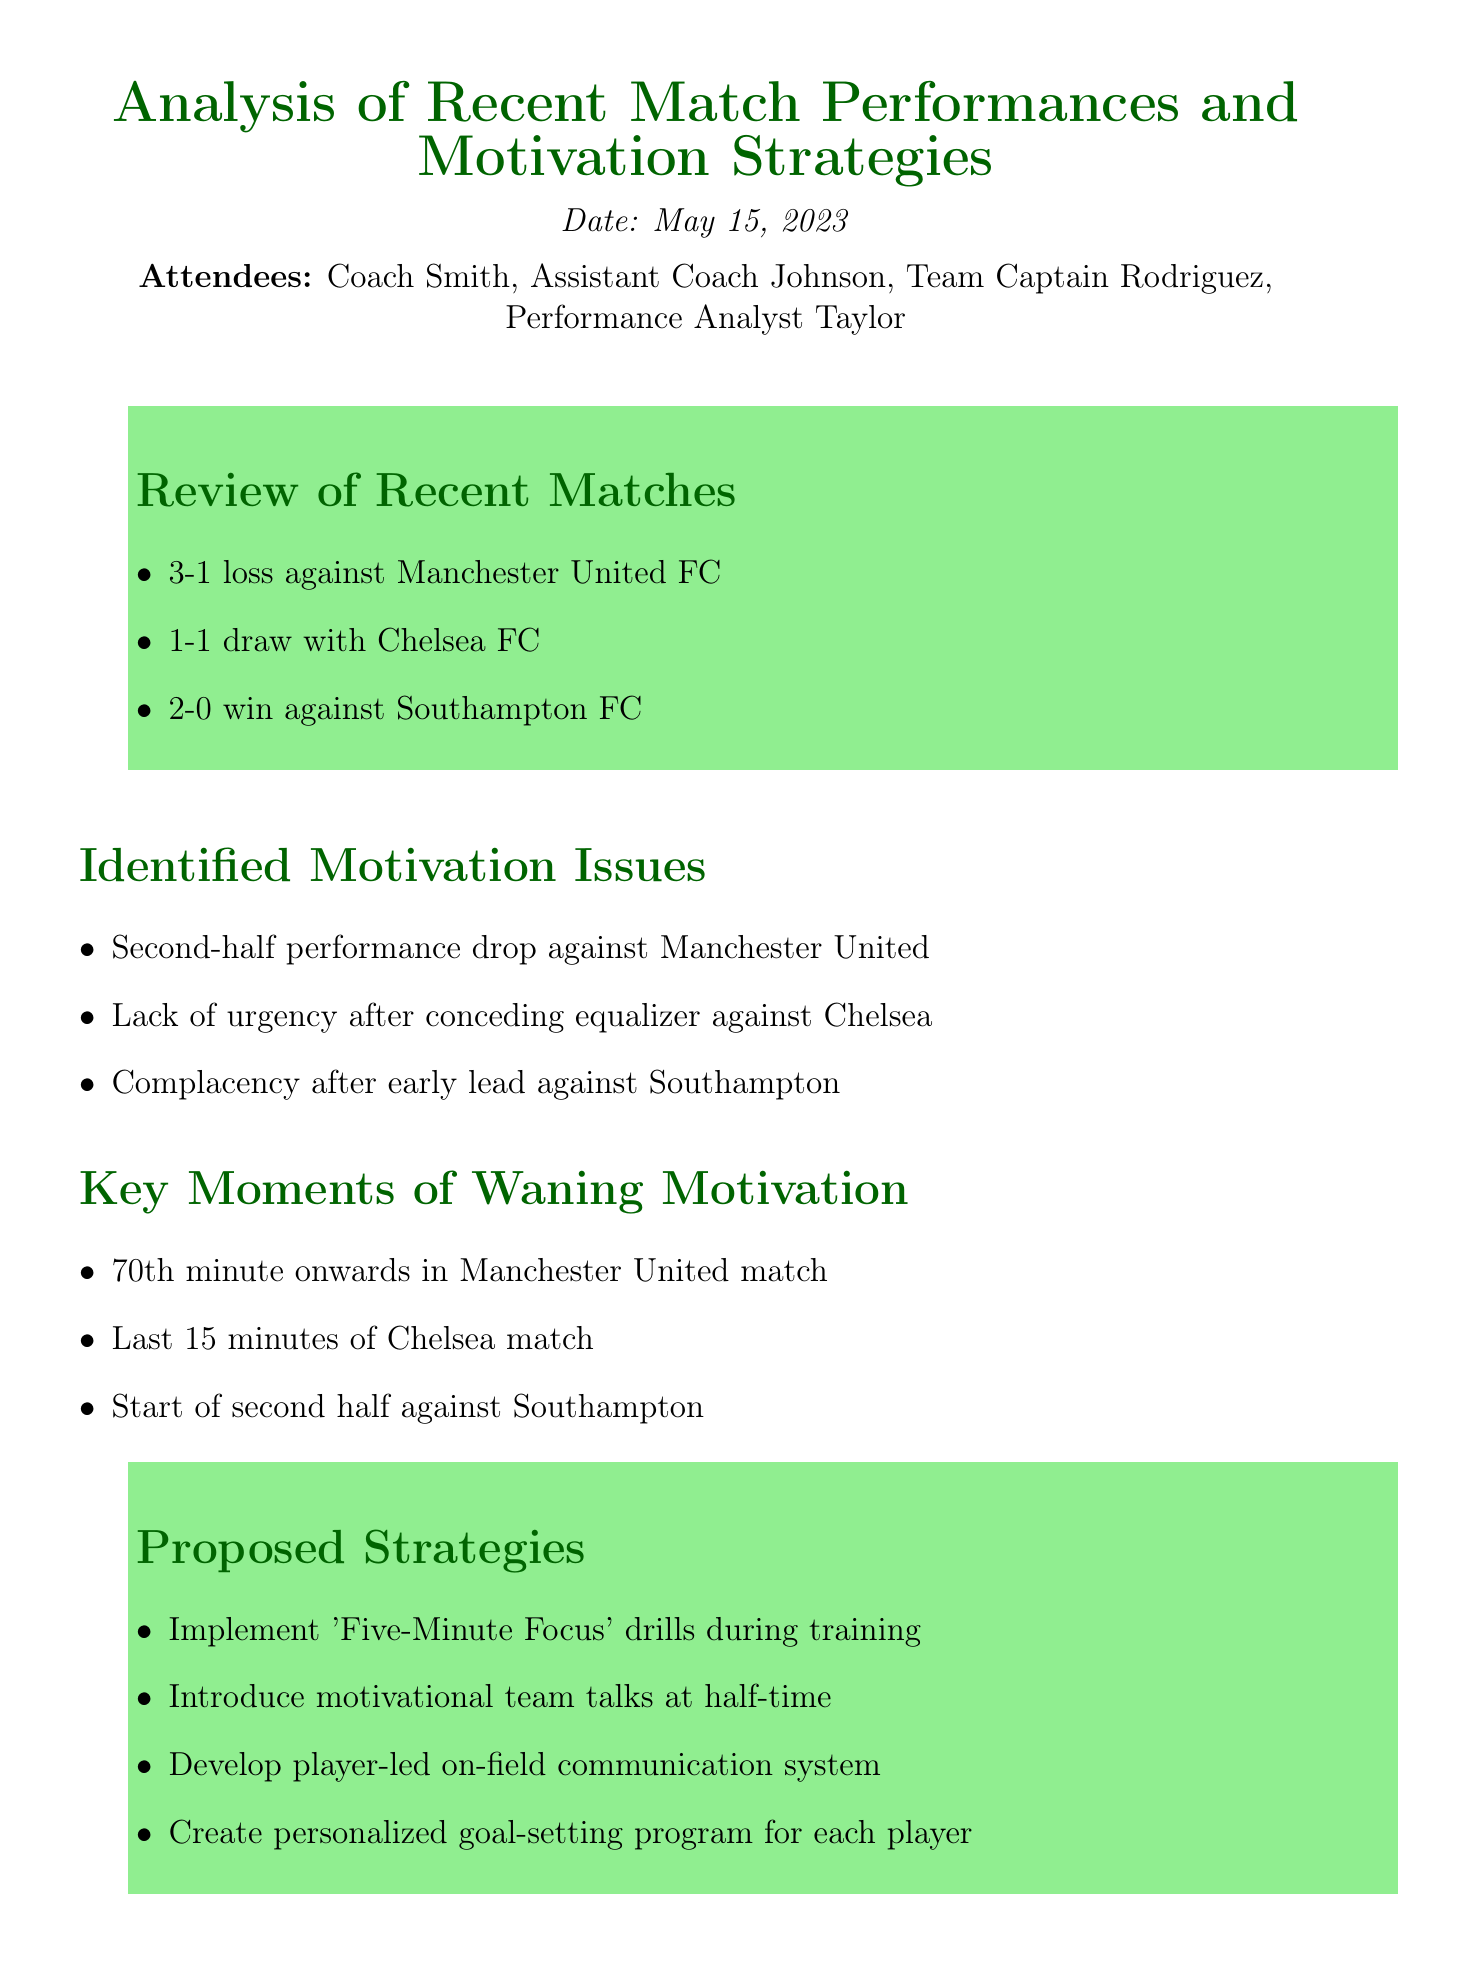What was the date of the meeting? The date of the meeting is listed at the beginning of the document.
Answer: May 15, 2023 Who was present at the meeting? The attendees' names are specified in the initial section of the document.
Answer: Coach Smith, Assistant Coach Johnson, Team Captain Rodriguez, Performance Analyst Taylor What was the outcome of the match against Manchester United? The outcome of this match is mentioned in the review of recent matches.
Answer: 3-1 loss What are the key moments of waning motivation identified? The document lists three specific times when motivation waned in matches.
Answer: 70th minute onwards in Manchester United match, Last 15 minutes of Chelsea match, Start of second half against Southampton What strategy involves the development of a communication system? This strategy aims to enhance on-field team communication and is mentioned in the proposed strategies.
Answer: Develop player-led on-field communication system Who is responsible for designing the 'Five-Minute Focus' drills? The action items section states who will handle this task after the meeting.
Answer: Coach Smith What issue was identified regarding the Chelsea match? The document discusses a specific motivation issue related to this match.
Answer: Lack of urgency after conceding equalizer What was the proposed strategy to address motivation during training? The strategies include various methods to improve motivation during matches.
Answer: Implement 'Five-Minute Focus' drills during training 